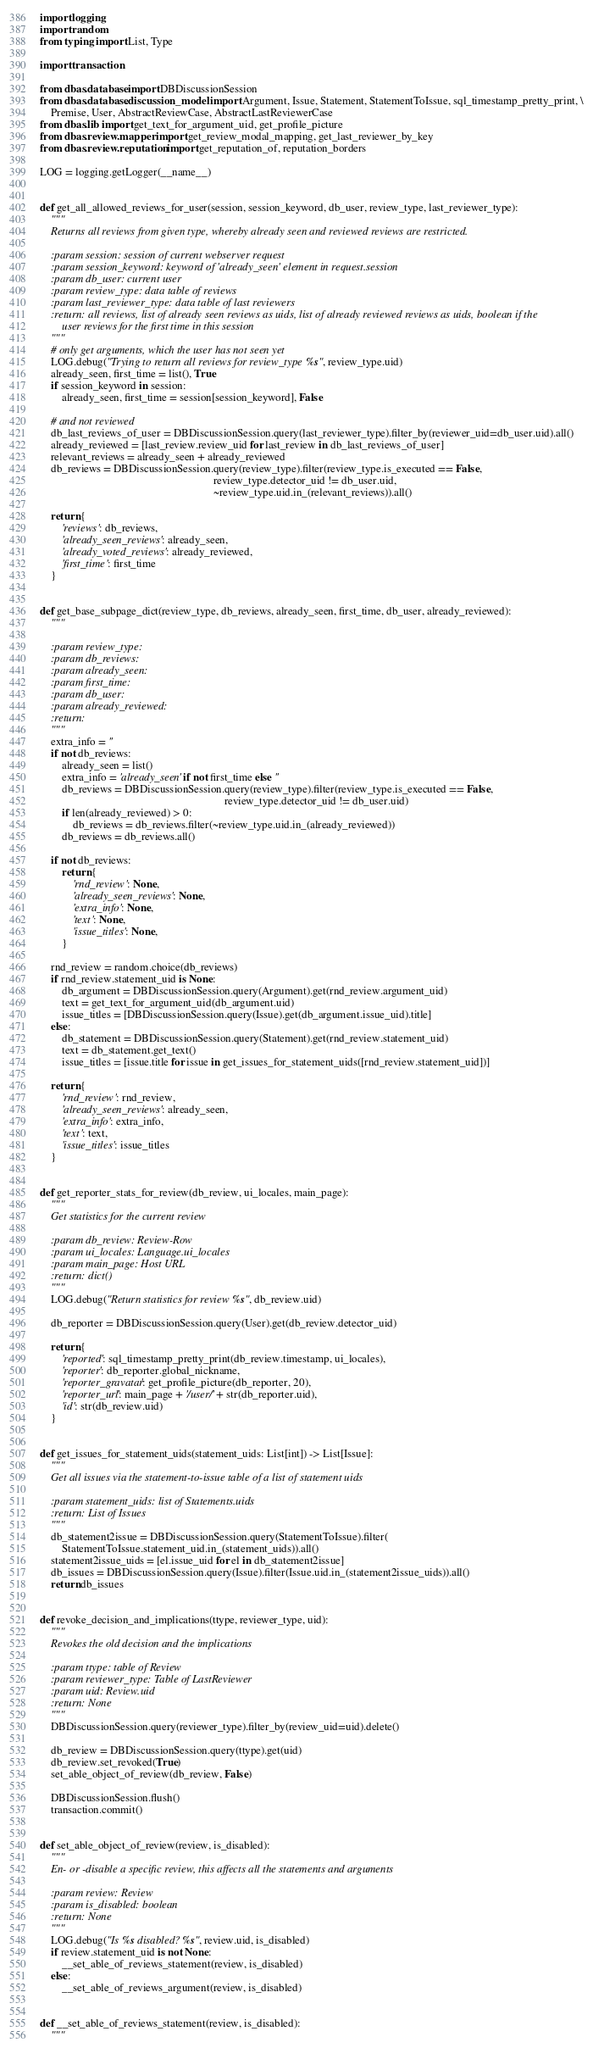Convert code to text. <code><loc_0><loc_0><loc_500><loc_500><_Python_>import logging
import random
from typing import List, Type

import transaction

from dbas.database import DBDiscussionSession
from dbas.database.discussion_model import Argument, Issue, Statement, StatementToIssue, sql_timestamp_pretty_print, \
    Premise, User, AbstractReviewCase, AbstractLastReviewerCase
from dbas.lib import get_text_for_argument_uid, get_profile_picture
from dbas.review.mapper import get_review_modal_mapping, get_last_reviewer_by_key
from dbas.review.reputation import get_reputation_of, reputation_borders

LOG = logging.getLogger(__name__)


def get_all_allowed_reviews_for_user(session, session_keyword, db_user, review_type, last_reviewer_type):
    """
    Returns all reviews from given type, whereby already seen and reviewed reviews are restricted.

    :param session: session of current webserver request
    :param session_keyword: keyword of 'already_seen' element in request.session
    :param db_user: current user
    :param review_type: data table of reviews
    :param last_reviewer_type: data table of last reviewers
    :return: all reviews, list of already seen reviews as uids, list of already reviewed reviews as uids, boolean if the
        user reviews for the first time in this session
    """
    # only get arguments, which the user has not seen yet
    LOG.debug("Trying to return all reviews for review_type %s", review_type.uid)
    already_seen, first_time = list(), True
    if session_keyword in session:
        already_seen, first_time = session[session_keyword], False

    # and not reviewed
    db_last_reviews_of_user = DBDiscussionSession.query(last_reviewer_type).filter_by(reviewer_uid=db_user.uid).all()
    already_reviewed = [last_review.review_uid for last_review in db_last_reviews_of_user]
    relevant_reviews = already_seen + already_reviewed
    db_reviews = DBDiscussionSession.query(review_type).filter(review_type.is_executed == False,
                                                               review_type.detector_uid != db_user.uid,
                                                               ~review_type.uid.in_(relevant_reviews)).all()

    return {
        'reviews': db_reviews,
        'already_seen_reviews': already_seen,
        'already_voted_reviews': already_reviewed,
        'first_time': first_time
    }


def get_base_subpage_dict(review_type, db_reviews, already_seen, first_time, db_user, already_reviewed):
    """

    :param review_type:
    :param db_reviews:
    :param already_seen:
    :param first_time:
    :param db_user:
    :param already_reviewed:
    :return:
    """
    extra_info = ''
    if not db_reviews:
        already_seen = list()
        extra_info = 'already_seen' if not first_time else ''
        db_reviews = DBDiscussionSession.query(review_type).filter(review_type.is_executed == False,
                                                                   review_type.detector_uid != db_user.uid)
        if len(already_reviewed) > 0:
            db_reviews = db_reviews.filter(~review_type.uid.in_(already_reviewed))
        db_reviews = db_reviews.all()

    if not db_reviews:
        return {
            'rnd_review': None,
            'already_seen_reviews': None,
            'extra_info': None,
            'text': None,
            'issue_titles': None,
        }

    rnd_review = random.choice(db_reviews)
    if rnd_review.statement_uid is None:
        db_argument = DBDiscussionSession.query(Argument).get(rnd_review.argument_uid)
        text = get_text_for_argument_uid(db_argument.uid)
        issue_titles = [DBDiscussionSession.query(Issue).get(db_argument.issue_uid).title]
    else:
        db_statement = DBDiscussionSession.query(Statement).get(rnd_review.statement_uid)
        text = db_statement.get_text()
        issue_titles = [issue.title for issue in get_issues_for_statement_uids([rnd_review.statement_uid])]

    return {
        'rnd_review': rnd_review,
        'already_seen_reviews': already_seen,
        'extra_info': extra_info,
        'text': text,
        'issue_titles': issue_titles
    }


def get_reporter_stats_for_review(db_review, ui_locales, main_page):
    """
    Get statistics for the current review

    :param db_review: Review-Row
    :param ui_locales: Language.ui_locales
    :param main_page: Host URL
    :return: dict()
    """
    LOG.debug("Return statistics for review %s", db_review.uid)

    db_reporter = DBDiscussionSession.query(User).get(db_review.detector_uid)

    return {
        'reported': sql_timestamp_pretty_print(db_review.timestamp, ui_locales),
        'reporter': db_reporter.global_nickname,
        'reporter_gravatar': get_profile_picture(db_reporter, 20),
        'reporter_url': main_page + '/user/' + str(db_reporter.uid),
        'id': str(db_review.uid)
    }


def get_issues_for_statement_uids(statement_uids: List[int]) -> List[Issue]:
    """
    Get all issues via the statement-to-issue table of a list of statement uids

    :param statement_uids: list of Statements.uids
    :return: List of Issues
    """
    db_statement2issue = DBDiscussionSession.query(StatementToIssue).filter(
        StatementToIssue.statement_uid.in_(statement_uids)).all()
    statement2issue_uids = [el.issue_uid for el in db_statement2issue]
    db_issues = DBDiscussionSession.query(Issue).filter(Issue.uid.in_(statement2issue_uids)).all()
    return db_issues


def revoke_decision_and_implications(ttype, reviewer_type, uid):
    """
    Revokes the old decision and the implications

    :param ttype: table of Review
    :param reviewer_type: Table of LastReviewer
    :param uid: Review.uid
    :return: None
    """
    DBDiscussionSession.query(reviewer_type).filter_by(review_uid=uid).delete()

    db_review = DBDiscussionSession.query(ttype).get(uid)
    db_review.set_revoked(True)
    set_able_object_of_review(db_review, False)

    DBDiscussionSession.flush()
    transaction.commit()


def set_able_object_of_review(review, is_disabled):
    """
    En- or -disable a specific review, this affects all the statements and arguments

    :param review: Review
    :param is_disabled: boolean
    :return: None
    """
    LOG.debug("Is %s disabled? %s", review.uid, is_disabled)
    if review.statement_uid is not None:
        __set_able_of_reviews_statement(review, is_disabled)
    else:
        __set_able_of_reviews_argument(review, is_disabled)


def __set_able_of_reviews_statement(review, is_disabled):
    """</code> 